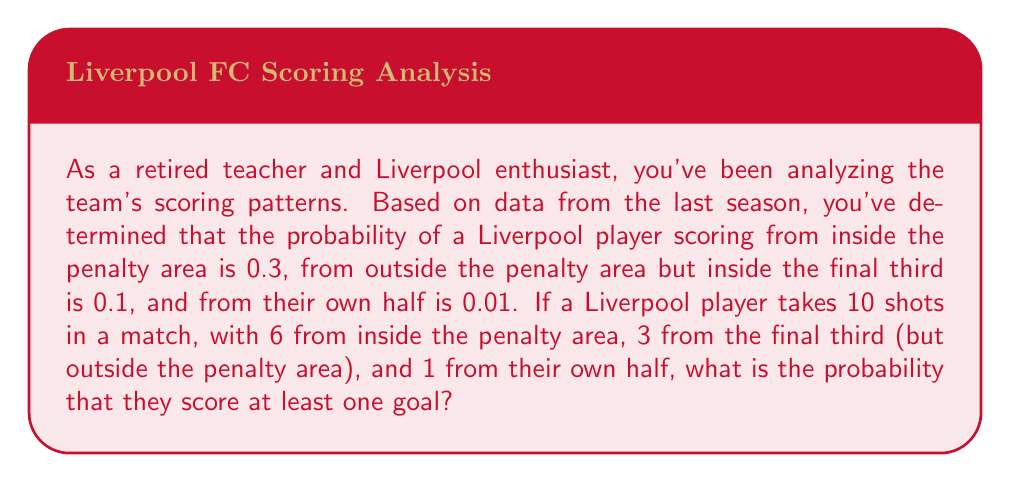What is the answer to this math problem? Let's approach this step-by-step:

1) First, we need to calculate the probability of not scoring from each position:
   - Inside penalty area: $1 - 0.3 = 0.7$
   - Final third (outside penalty area): $1 - 0.1 = 0.9$
   - Own half: $1 - 0.01 = 0.99$

2) Now, we need to calculate the probability of not scoring from any of the shots:
   - 6 shots from inside penalty area: $0.7^6$
   - 3 shots from final third: $0.9^3$
   - 1 shot from own half: $0.99^1$

3) The probability of not scoring from any shot is the product of these probabilities:

   $$P(\text{no goals}) = 0.7^6 \times 0.9^3 \times 0.99^1$$

4) We can calculate this:
   
   $$P(\text{no goals}) = 0.118 \times 0.729 \times 0.99 = 0.0851$$

5) The probability of scoring at least one goal is the complement of this probability:

   $$P(\text{at least one goal}) = 1 - P(\text{no goals}) = 1 - 0.0851 = 0.9149$$

6) Convert to a percentage:

   $$0.9149 \times 100\% = 91.49\%$$
Answer: The probability that a Liverpool player scores at least one goal is approximately 91.49%. 